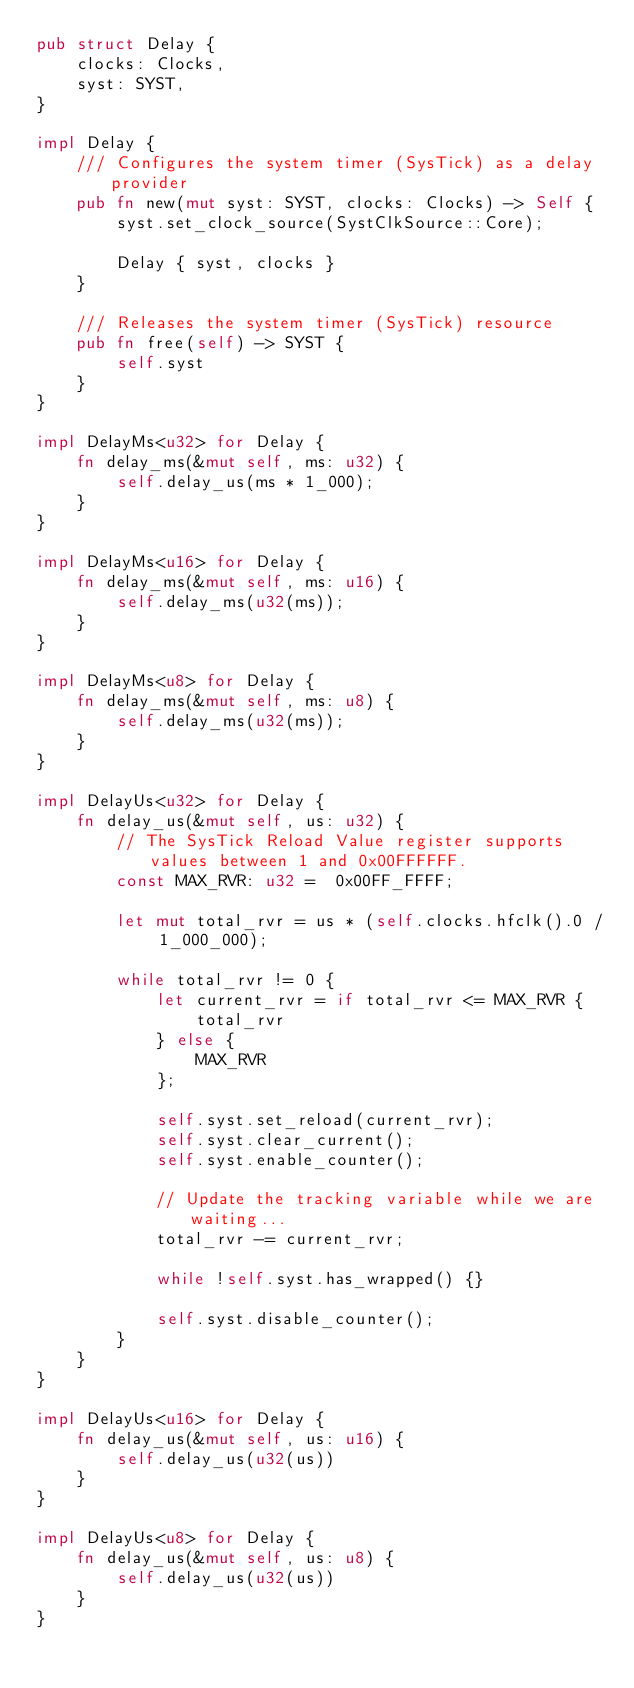<code> <loc_0><loc_0><loc_500><loc_500><_Rust_>pub struct Delay {
    clocks: Clocks,
    syst: SYST,
}

impl Delay {
    /// Configures the system timer (SysTick) as a delay provider
    pub fn new(mut syst: SYST, clocks: Clocks) -> Self {
        syst.set_clock_source(SystClkSource::Core);

        Delay { syst, clocks }
    }

    /// Releases the system timer (SysTick) resource
    pub fn free(self) -> SYST {
        self.syst
    }
}

impl DelayMs<u32> for Delay {
    fn delay_ms(&mut self, ms: u32) {
        self.delay_us(ms * 1_000);
    }
}

impl DelayMs<u16> for Delay {
    fn delay_ms(&mut self, ms: u16) {
        self.delay_ms(u32(ms));
    }
}

impl DelayMs<u8> for Delay {
    fn delay_ms(&mut self, ms: u8) {
        self.delay_ms(u32(ms));
    }
}

impl DelayUs<u32> for Delay {
    fn delay_us(&mut self, us: u32) {
        // The SysTick Reload Value register supports values between 1 and 0x00FFFFFF.
        const MAX_RVR: u32 =  0x00FF_FFFF;

        let mut total_rvr = us * (self.clocks.hfclk().0 / 1_000_000);

        while total_rvr != 0 {
            let current_rvr = if total_rvr <= MAX_RVR {
                total_rvr
            } else {
                MAX_RVR
            };

            self.syst.set_reload(current_rvr);
            self.syst.clear_current();
            self.syst.enable_counter();

            // Update the tracking variable while we are waiting...
            total_rvr -= current_rvr;

            while !self.syst.has_wrapped() {}

            self.syst.disable_counter();
        }
    }
}

impl DelayUs<u16> for Delay {
    fn delay_us(&mut self, us: u16) {
        self.delay_us(u32(us))
    }
}

impl DelayUs<u8> for Delay {
    fn delay_us(&mut self, us: u8) {
        self.delay_us(u32(us))
    }
}
</code> 